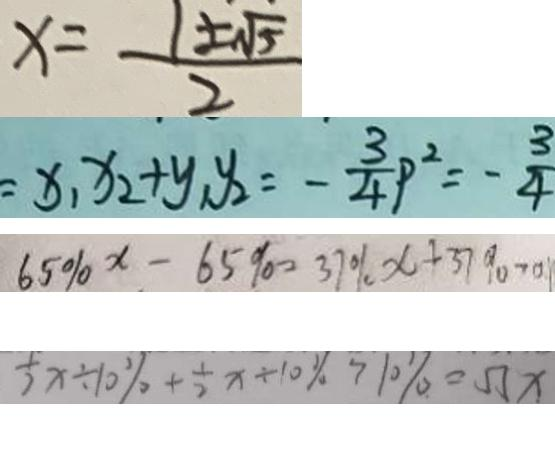Convert formula to latex. <formula><loc_0><loc_0><loc_500><loc_500>x = \frac { 1 \pm \sqrt { 5 } } { 2 } 
 = x _ { 1 } x _ { 2 } + y _ { 1 } y _ { 2 } = - \frac { 3 } { 4 } P ^ { 2 } = - \frac { 3 } { 4 } 
 6 5 \% x - 6 5 \% = 3 7 \% x + 3 7 \% > 0 . 
 \frac { 1 } { 2 } x \div 1 0 \% + \frac { 1 } { 2 } x \div 1 0 \% > 1 0 \% = 5 5 x</formula> 